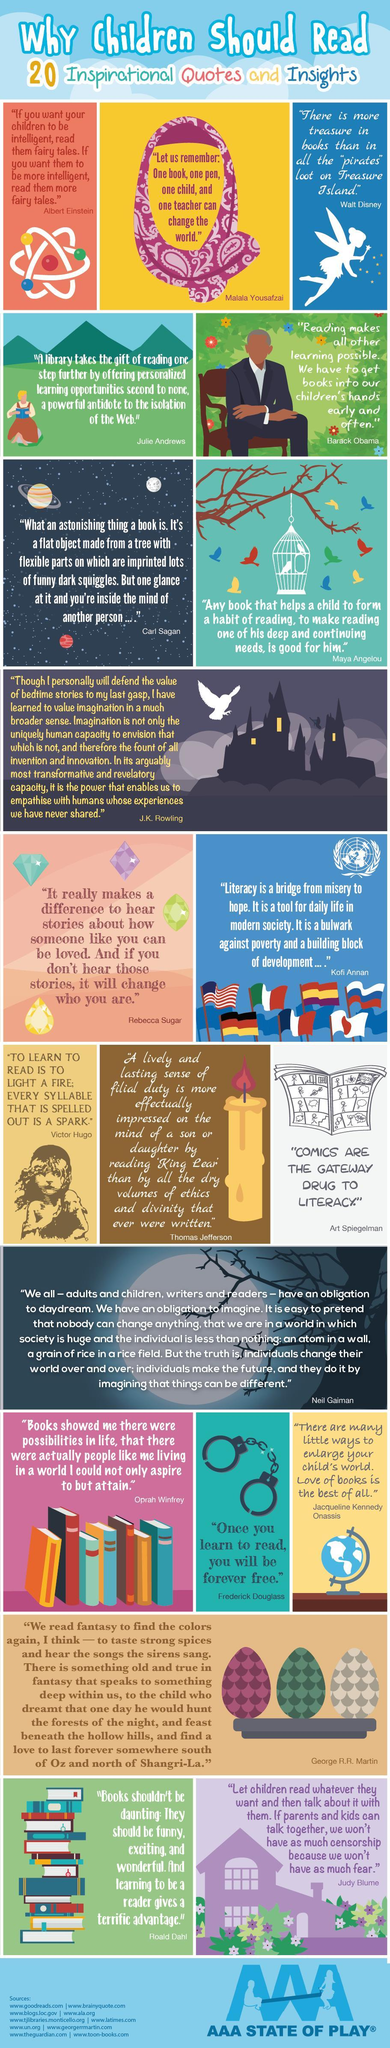How many quotes are given in the image ?
Answer the question with a short phrase. 20 